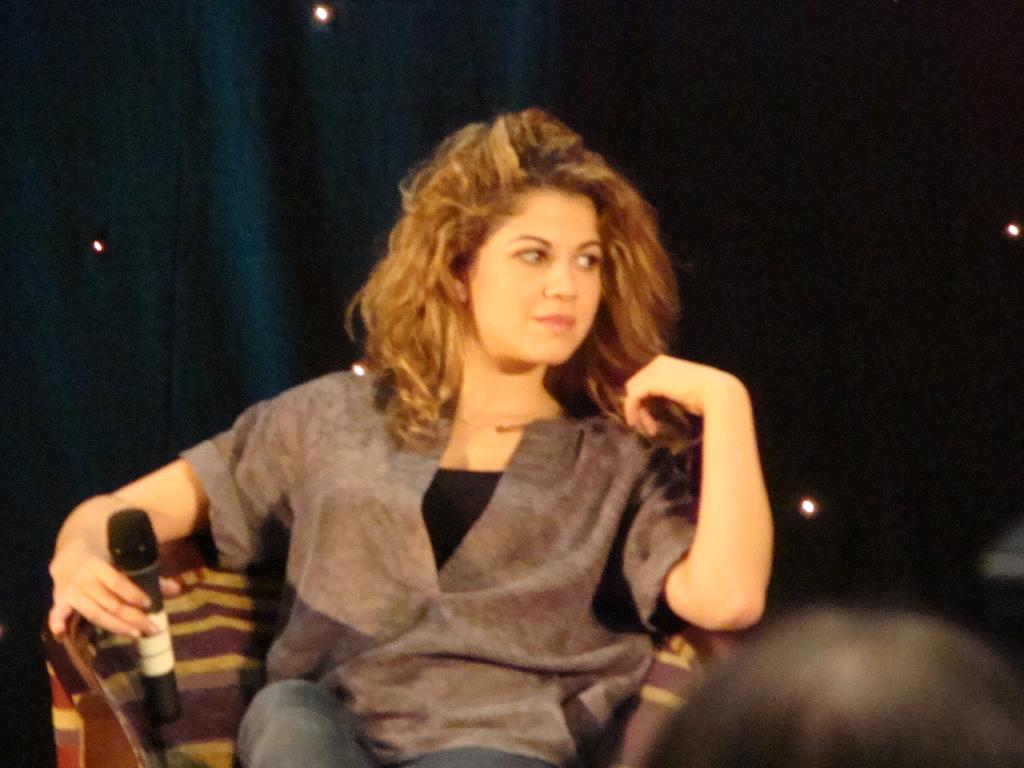What is the woman in the image doing? The woman is sitting and holding a mic. What can be seen in the background of the image? There is a curtain in the background of the image. What else is visible in the image? There are lights visible in the image. What type of bead is used to decorate the drain in the image? There is no drain or bead present in the image. 